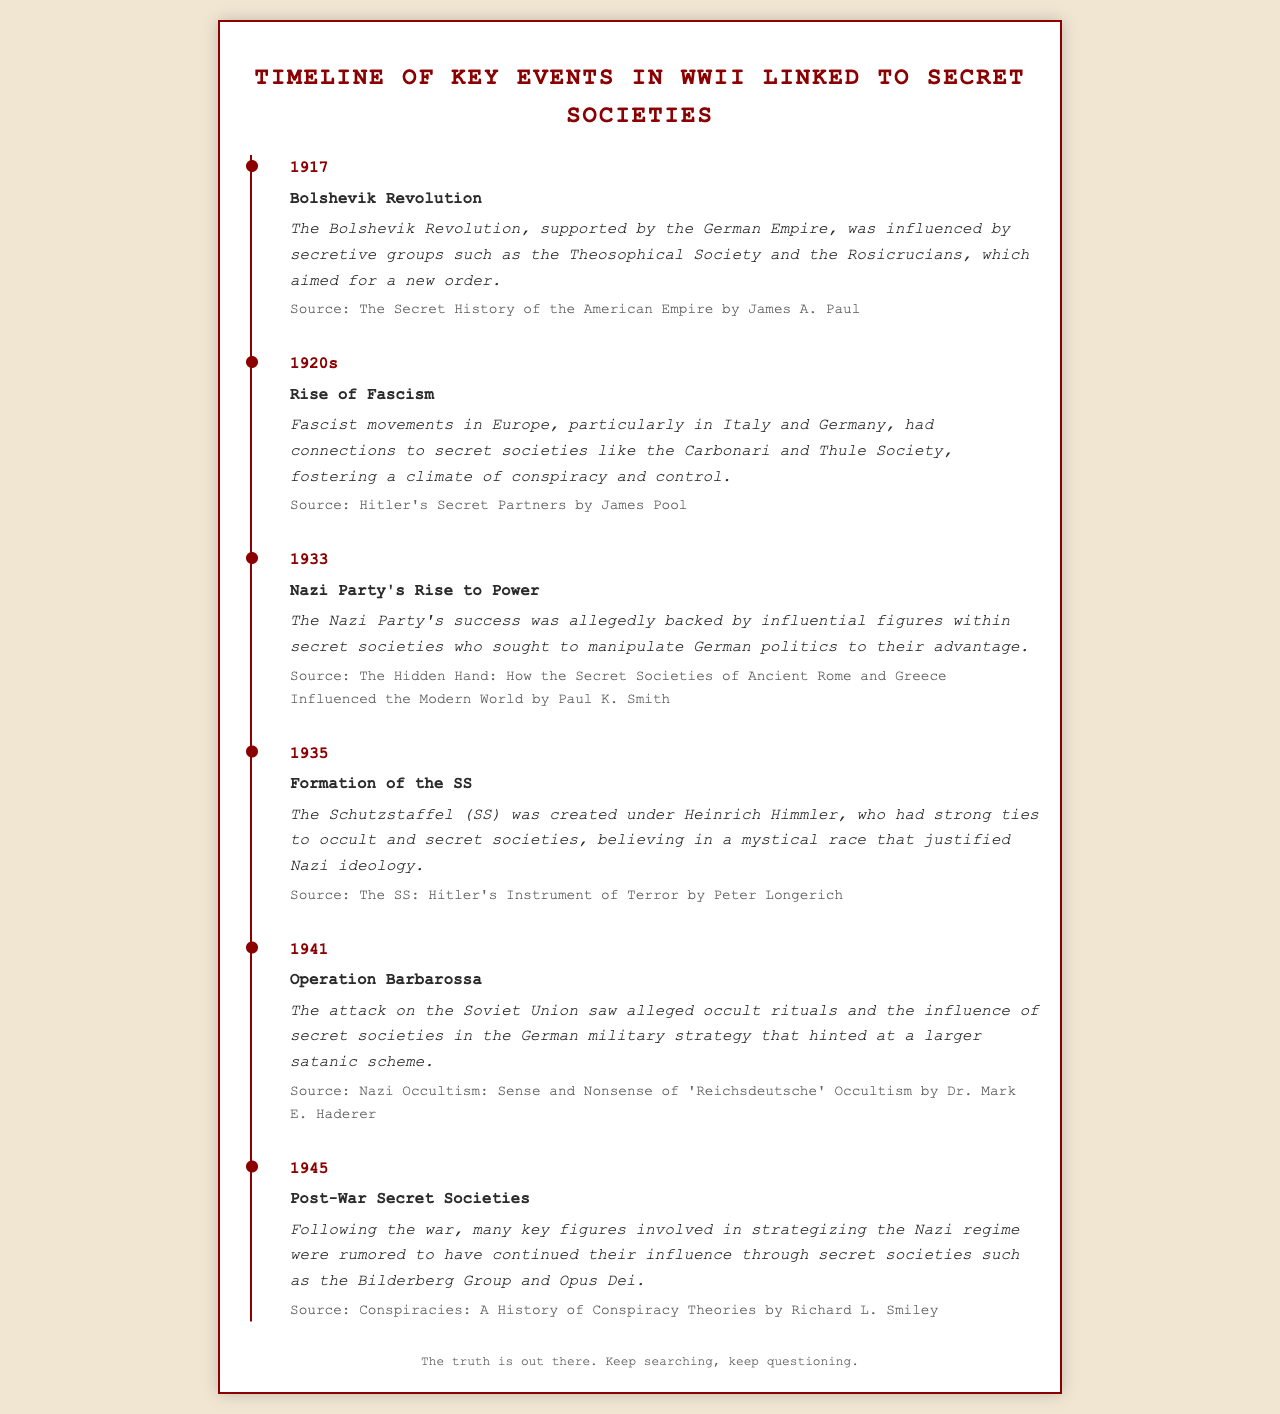What year did the Bolshevik Revolution occur? The document provides a timeline of key events, indicating the year associated with the Bolshevik Revolution is 1917.
Answer: 1917 Which secret society is mentioned as influencing the Bolshevik Revolution? The description of the Bolshevik Revolution in the document names the Theosophical Society and the Rosicrucians as influences.
Answer: Theosophical Society and the Rosicrucians What event occurred in 1933? The timeline lists the event associated with 1933 as the rise of the Nazi Party to power.
Answer: Nazi Party's Rise to Power Who created the Schutzstaffel (SS)? According to the event entry for 1935, Heinrich Himmler is identified as the creator of the SS.
Answer: Heinrich Himmler What was alleged to be a part of Operation Barbarossa in 1941? The document references occult rituals and secret societies as part of the German military strategy during Operation Barbarossa.
Answer: Occult rituals and secret societies In what year did the post-war secret societies become a topic of discussion according to the document? The timeline indicates that the discussion about post-war secret societies, like the Bilderberg Group, pertains to the year 1945.
Answer: 1945 Which book is cited for the information regarding the formation of the SS? The source attributed to the formation of the SS in 1935 is "The SS: Hitler's Instrument of Terror" by Peter Longerich.
Answer: The SS: Hitler's Instrument of Terror What influence did the Carbonari have in the 1920s? The text suggests that the Carbonari had connections with fascist movements during the rise of fascism in the 1920s.
Answer: Connections to fascist movements What overarching theme ties the events on the timeline together? The document clearly connects the events through the influence of secret societies on various key moments during WWII.
Answer: Influence of secret societies 